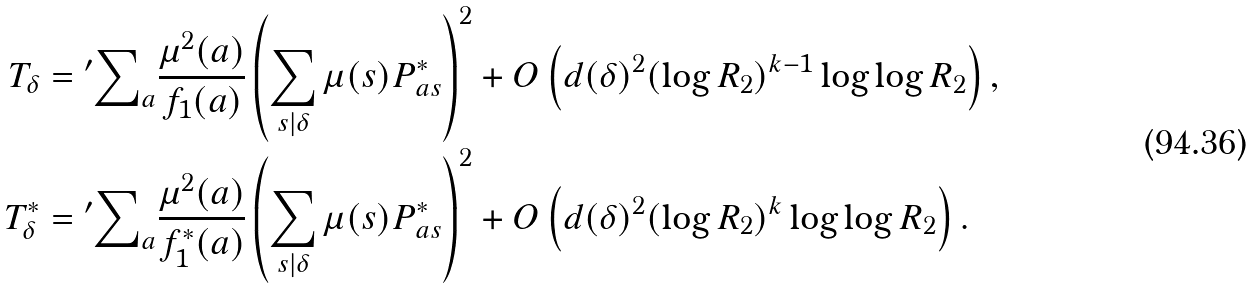<formula> <loc_0><loc_0><loc_500><loc_500>T _ { \delta } & = { ^ { \prime } } { \sum } _ { a } \frac { \mu ^ { 2 } ( a ) } { f _ { 1 } ( a ) } \left ( \sum _ { s | \delta } \mu ( s ) P _ { a s } ^ { * } \right ) ^ { 2 } + O \left ( d ( \delta ) ^ { 2 } ( \log { R _ { 2 } } ) ^ { k - 1 } \log \log { R _ { 2 } } \right ) , \\ T _ { \delta } ^ { * } & = { ^ { \prime } } { \sum } _ { a } \frac { \mu ^ { 2 } ( a ) } { f _ { 1 } ^ { * } ( a ) } \left ( \sum _ { s | \delta } \mu ( s ) P _ { a s } ^ { * } \right ) ^ { 2 } + O \left ( d ( \delta ) ^ { 2 } ( \log { R _ { 2 } } ) ^ { k } \log \log { R _ { 2 } } \right ) .</formula> 